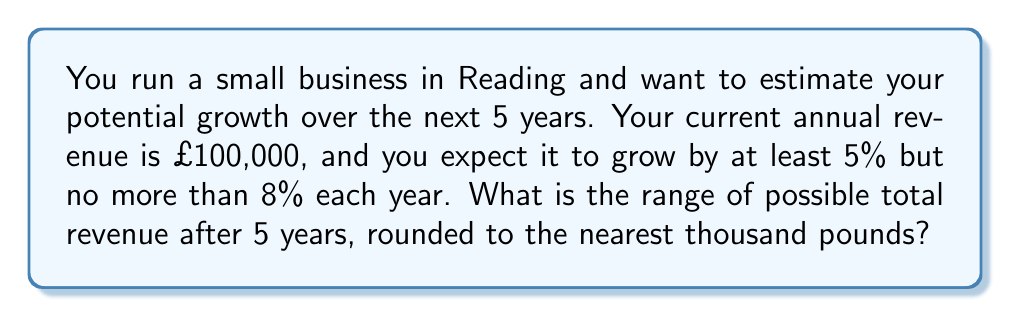Show me your answer to this math problem. Let's approach this step-by-step:

1) We need to calculate the minimum and maximum possible revenue after 5 years.

2) For the minimum:
   - Growth rate: 5% = 0.05
   - Initial revenue: £100,000
   - Formula: $100,000 * (1.05)^5$
   
   $$100,000 * (1.05)^5 = 100,000 * 1.2762815625 = 127,628.15625$$

3) For the maximum:
   - Growth rate: 8% = 0.08
   - Initial revenue: £100,000
   - Formula: $100,000 * (1.08)^5$
   
   $$100,000 * (1.08)^5 = 100,000 * 1.4693280768 = 146,932.80768$$

4) Rounding to the nearest thousand:
   - Minimum: £128,000
   - Maximum: £147,000

5) Therefore, the range of possible total revenue after 5 years is £128,000 to £147,000.
Answer: £128,000 to £147,000 